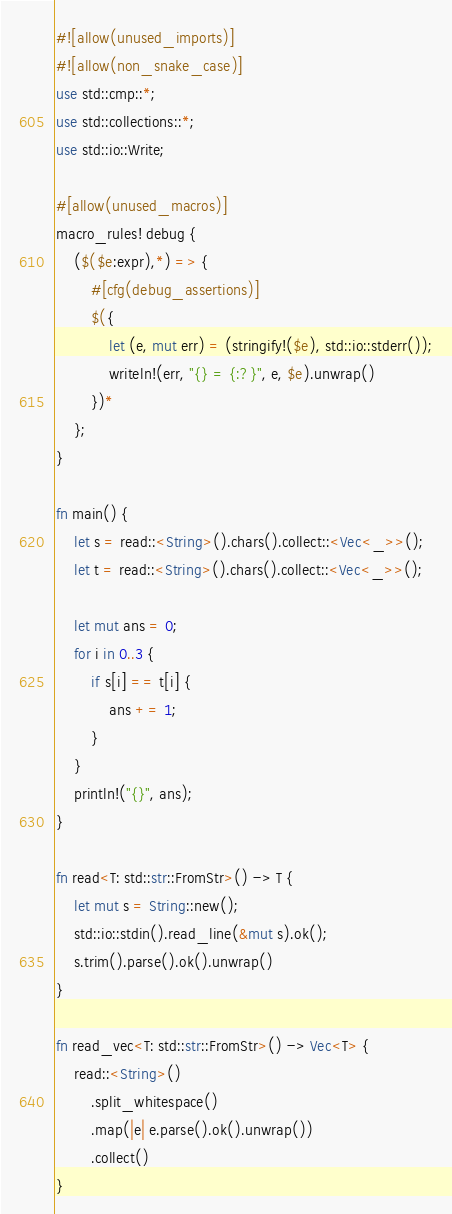Convert code to text. <code><loc_0><loc_0><loc_500><loc_500><_Rust_>#![allow(unused_imports)]
#![allow(non_snake_case)]
use std::cmp::*;
use std::collections::*;
use std::io::Write;

#[allow(unused_macros)]
macro_rules! debug {
    ($($e:expr),*) => {
        #[cfg(debug_assertions)]
        $({
            let (e, mut err) = (stringify!($e), std::io::stderr());
            writeln!(err, "{} = {:?}", e, $e).unwrap()
        })*
    };
}

fn main() {
    let s = read::<String>().chars().collect::<Vec<_>>();
    let t = read::<String>().chars().collect::<Vec<_>>();

    let mut ans = 0;
    for i in 0..3 {
        if s[i] == t[i] {
            ans += 1;
        }
    }
    println!("{}", ans);
}

fn read<T: std::str::FromStr>() -> T {
    let mut s = String::new();
    std::io::stdin().read_line(&mut s).ok();
    s.trim().parse().ok().unwrap()
}

fn read_vec<T: std::str::FromStr>() -> Vec<T> {
    read::<String>()
        .split_whitespace()
        .map(|e| e.parse().ok().unwrap())
        .collect()
}
</code> 